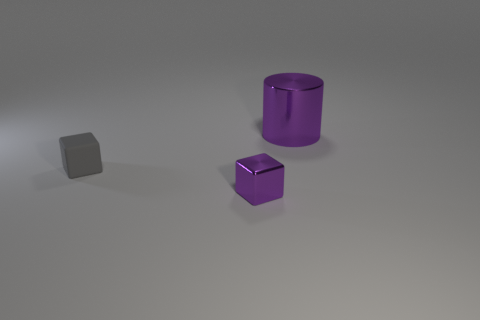There is a metallic thing to the left of the big purple metallic cylinder; what size is it?
Provide a succinct answer. Small. What is the shape of the metal object that is the same size as the gray rubber object?
Give a very brief answer. Cube. Is the material of the purple object in front of the big purple metallic thing the same as the small cube that is behind the small metallic object?
Your response must be concise. No. There is a purple thing right of the purple metallic thing left of the large metal cylinder; what is it made of?
Provide a succinct answer. Metal. There is a metal thing that is left of the purple shiny object behind the metallic object that is to the left of the big metallic thing; how big is it?
Your answer should be very brief. Small. Do the purple metal cylinder and the matte block have the same size?
Offer a terse response. No. There is a purple metallic thing that is behind the small shiny block; is it the same shape as the tiny object that is behind the metal block?
Ensure brevity in your answer.  No. There is a block that is behind the small metallic object; is there a gray cube that is in front of it?
Offer a very short reply. No. Is there a gray shiny object?
Offer a very short reply. No. What number of gray cubes have the same size as the gray rubber thing?
Provide a short and direct response. 0. 